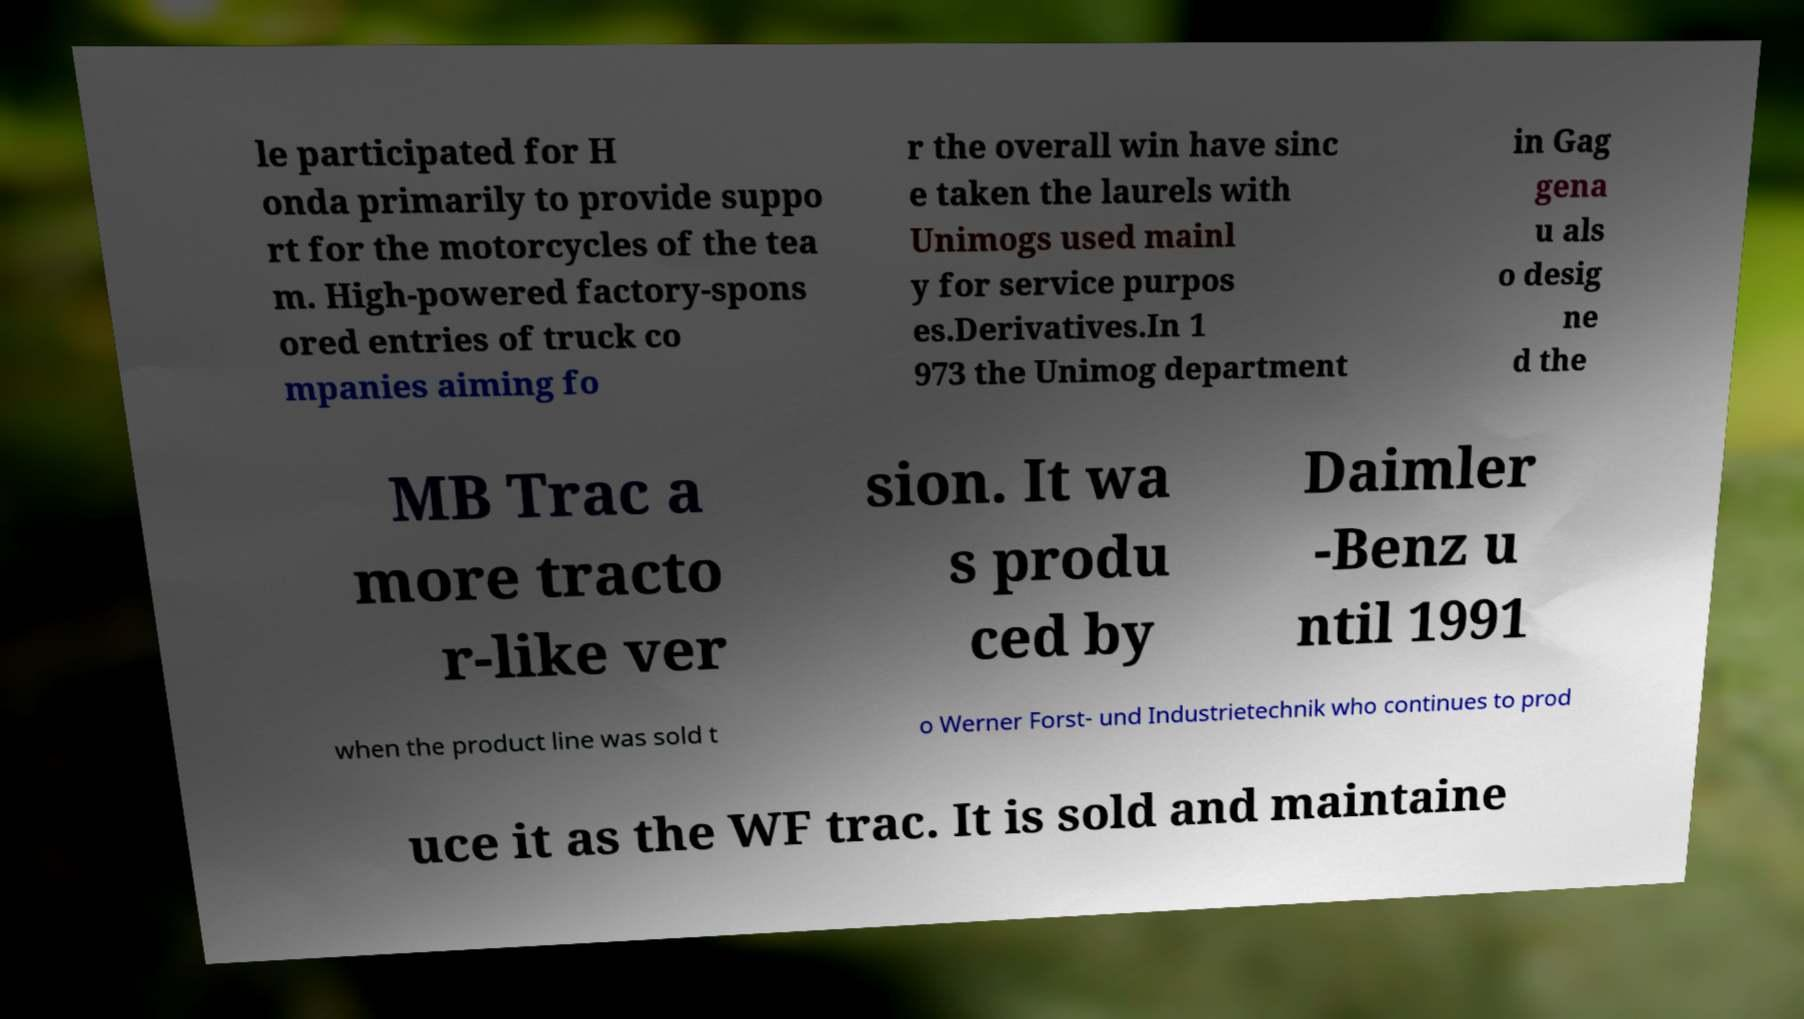Could you assist in decoding the text presented in this image and type it out clearly? le participated for H onda primarily to provide suppo rt for the motorcycles of the tea m. High-powered factory-spons ored entries of truck co mpanies aiming fo r the overall win have sinc e taken the laurels with Unimogs used mainl y for service purpos es.Derivatives.In 1 973 the Unimog department in Gag gena u als o desig ne d the MB Trac a more tracto r-like ver sion. It wa s produ ced by Daimler -Benz u ntil 1991 when the product line was sold t o Werner Forst- und Industrietechnik who continues to prod uce it as the WF trac. It is sold and maintaine 